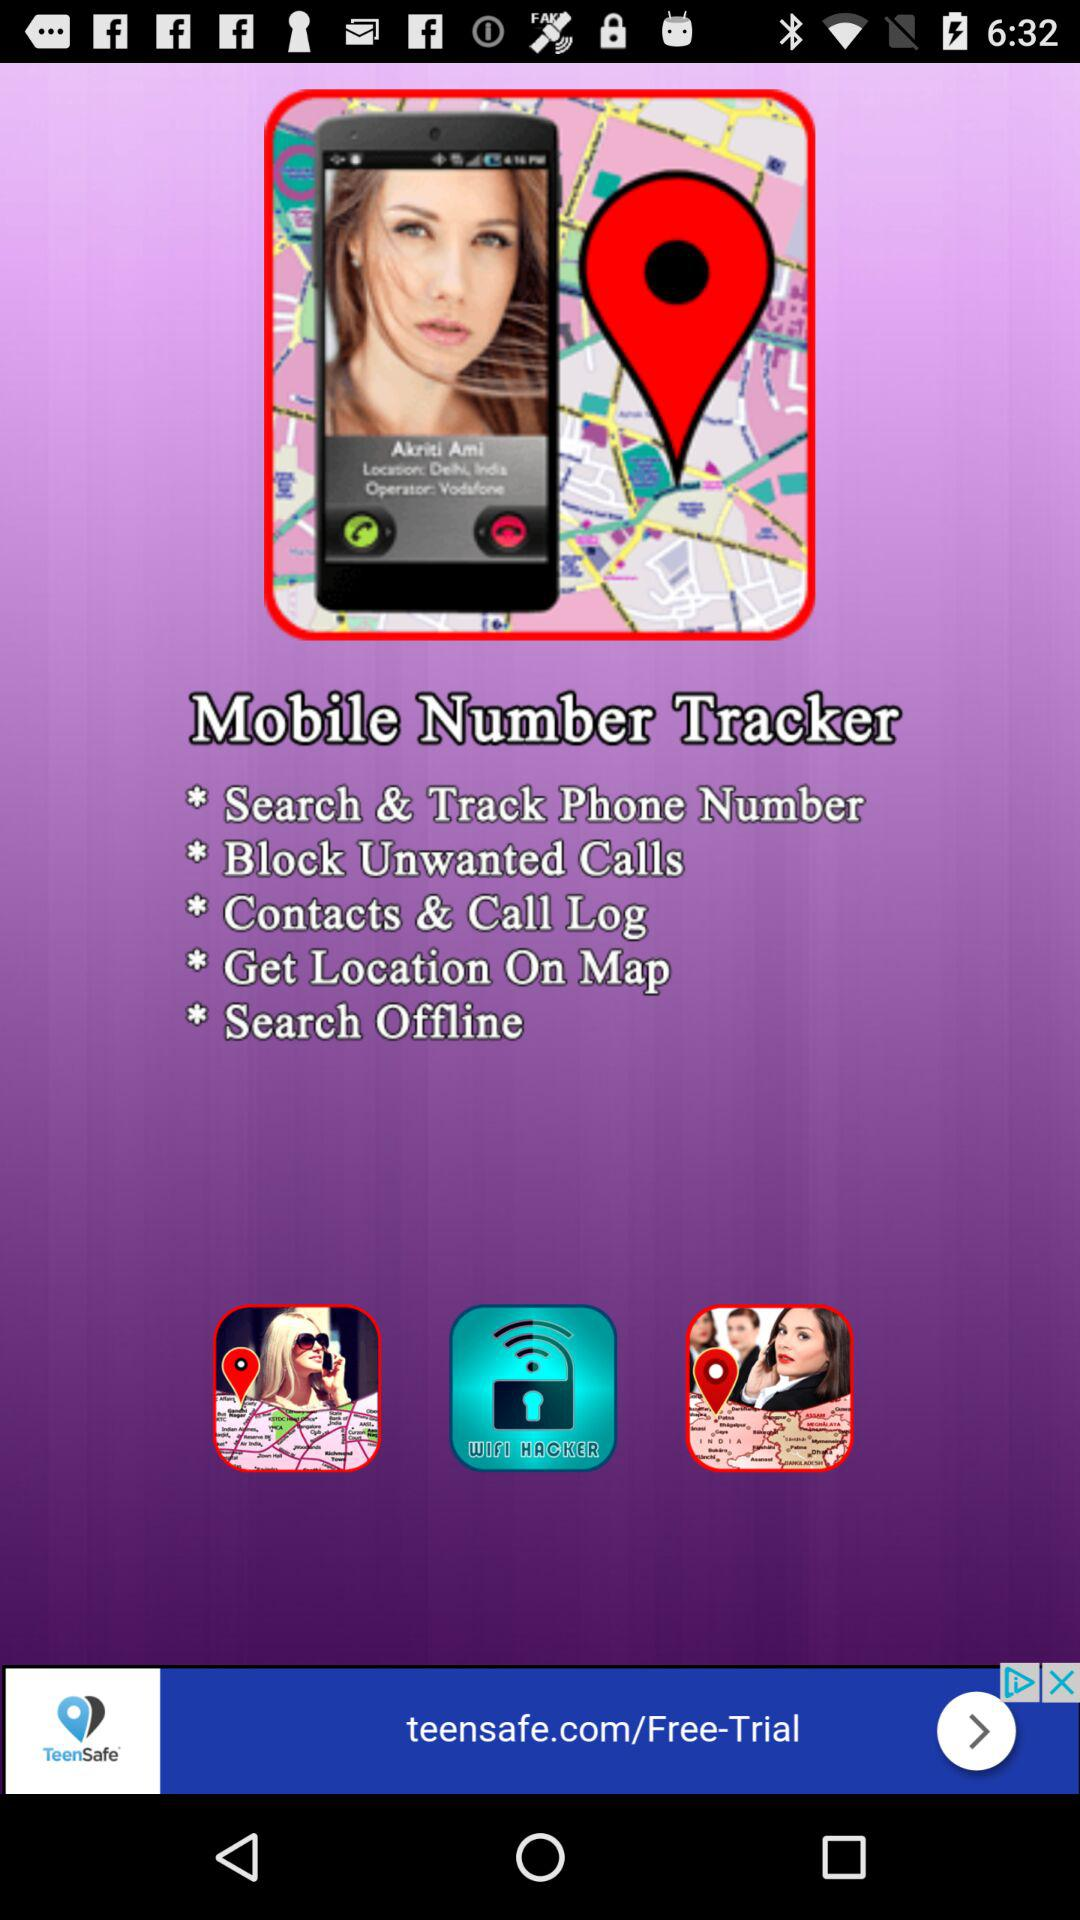What are the features available in "Mobile Number Tracker"? The features available are "Search & Track Phone Number", "Block Unwanted Calls", "Contacts & Call Log", "Get Location On Map" and "Search Offline". 